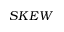Convert formula to latex. <formula><loc_0><loc_0><loc_500><loc_500>S K E W</formula> 